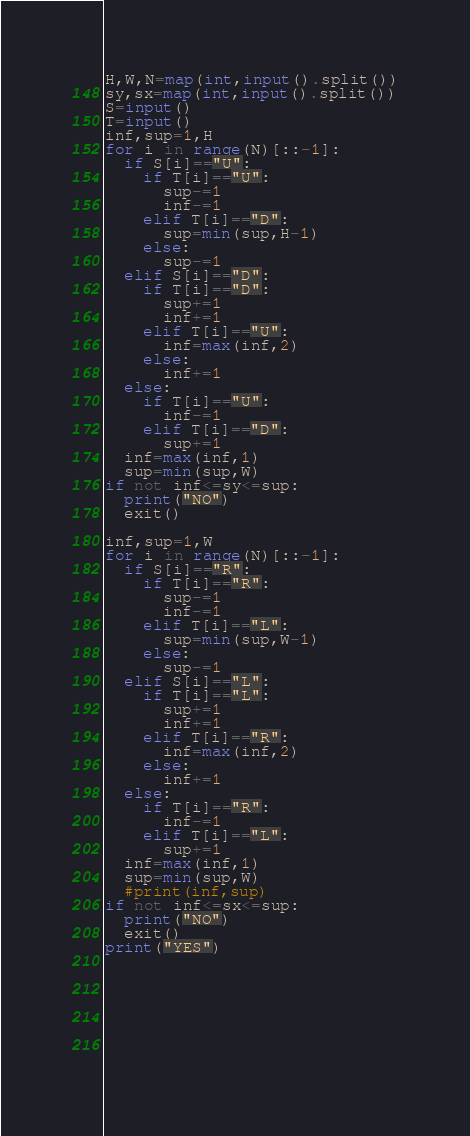<code> <loc_0><loc_0><loc_500><loc_500><_Python_>H,W,N=map(int,input().split())
sy,sx=map(int,input().split())
S=input()
T=input()
inf,sup=1,H
for i in range(N)[::-1]:
  if S[i]=="U":
    if T[i]=="U":
      sup-=1
      inf-=1
    elif T[i]=="D":
      sup=min(sup,H-1)
    else:
      sup-=1
  elif S[i]=="D":
    if T[i]=="D":
      sup+=1
      inf+=1
    elif T[i]=="U":
      inf=max(inf,2)
    else:
      inf+=1
  else:
    if T[i]=="U":
      inf-=1
    elif T[i]=="D":
      sup+=1
  inf=max(inf,1)
  sup=min(sup,W)
if not inf<=sy<=sup:
  print("NO")
  exit()
  
inf,sup=1,W
for i in range(N)[::-1]:
  if S[i]=="R":
    if T[i]=="R":
      sup-=1
      inf-=1
    elif T[i]=="L":
      sup=min(sup,W-1)
    else:
      sup-=1
  elif S[i]=="L":
    if T[i]=="L":
      sup+=1
      inf+=1
    elif T[i]=="R":
      inf=max(inf,2)
    else:
      inf+=1
  else:
    if T[i]=="R":
      inf-=1
    elif T[i]=="L":
      sup+=1
  inf=max(inf,1)
  sup=min(sup,W)
  #print(inf,sup)
if not inf<=sx<=sup:
  print("NO")
  exit()
print("YES") 
  
  
  
  
  
  
  
  </code> 